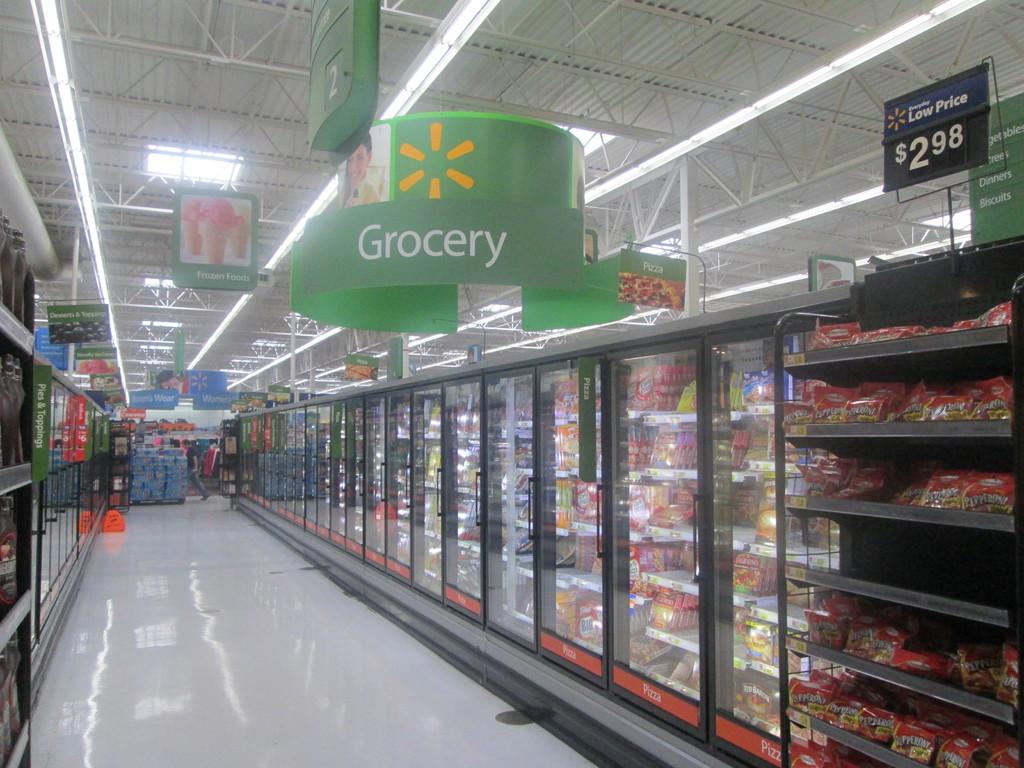What can you find in this aisle?
Offer a very short reply. Grocery. What is the number of the aisle?
Provide a short and direct response. 2. 